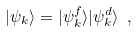<formula> <loc_0><loc_0><loc_500><loc_500>| \psi _ { k } \rangle = | \psi ^ { f } _ { k } \rangle | \psi ^ { d } _ { k } \rangle \ ,</formula> 